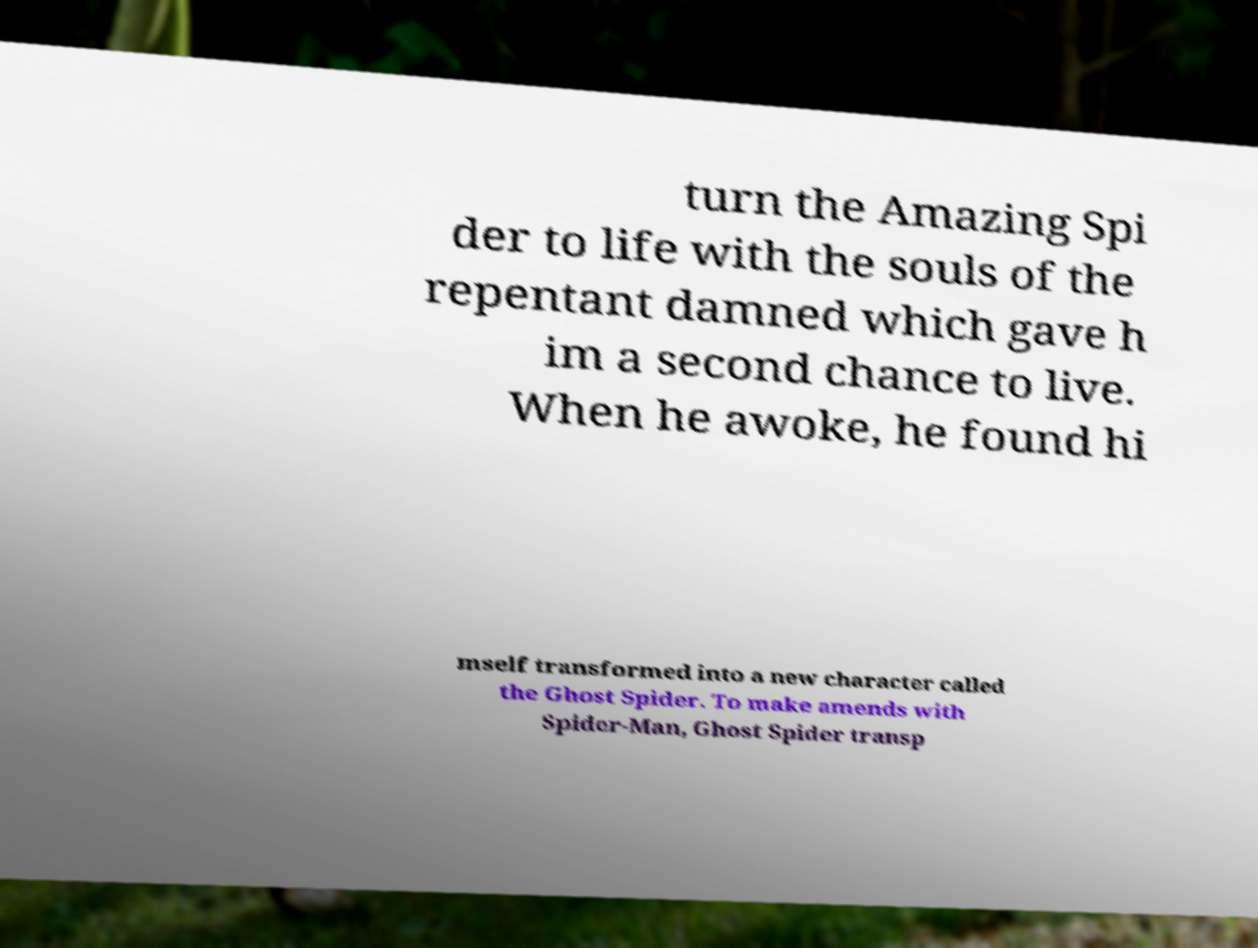Please identify and transcribe the text found in this image. turn the Amazing Spi der to life with the souls of the repentant damned which gave h im a second chance to live. When he awoke, he found hi mself transformed into a new character called the Ghost Spider. To make amends with Spider-Man, Ghost Spider transp 